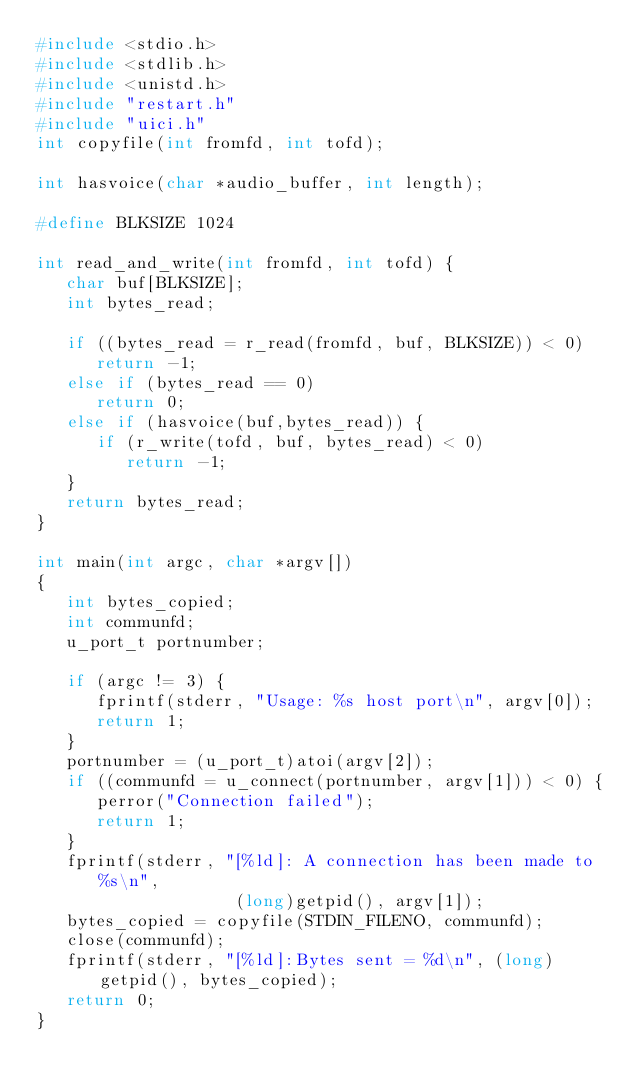Convert code to text. <code><loc_0><loc_0><loc_500><loc_500><_C_>#include <stdio.h>
#include <stdlib.h>
#include <unistd.h>
#include "restart.h"
#include "uici.h"
int copyfile(int fromfd, int tofd);

int hasvoice(char *audio_buffer, int length);

#define BLKSIZE 1024

int read_and_write(int fromfd, int tofd) {
   char buf[BLKSIZE];
   int bytes_read;

   if ((bytes_read = r_read(fromfd, buf, BLKSIZE)) < 0) 
      return -1;
   else if (bytes_read == 0)
      return 0;
   else if (hasvoice(buf,bytes_read)) {
      if (r_write(tofd, buf, bytes_read) < 0)
         return -1;
   }
   return bytes_read;
}

int main(int argc, char *argv[])
{
   int bytes_copied;
   int communfd;
   u_port_t portnumber;
 
   if (argc != 3) {
      fprintf(stderr, "Usage: %s host port\n", argv[0]);
      return 1;
   }
   portnumber = (u_port_t)atoi(argv[2]);
   if ((communfd = u_connect(portnumber, argv[1])) < 0) {
      perror("Connection failed");
      return 1;
   }
   fprintf(stderr, "[%ld]: A connection has been made to %s\n",
                    (long)getpid(), argv[1]);
   bytes_copied = copyfile(STDIN_FILENO, communfd);
   close(communfd);
   fprintf(stderr, "[%ld]:Bytes sent = %d\n", (long) getpid(), bytes_copied);
   return 0;
}
</code> 